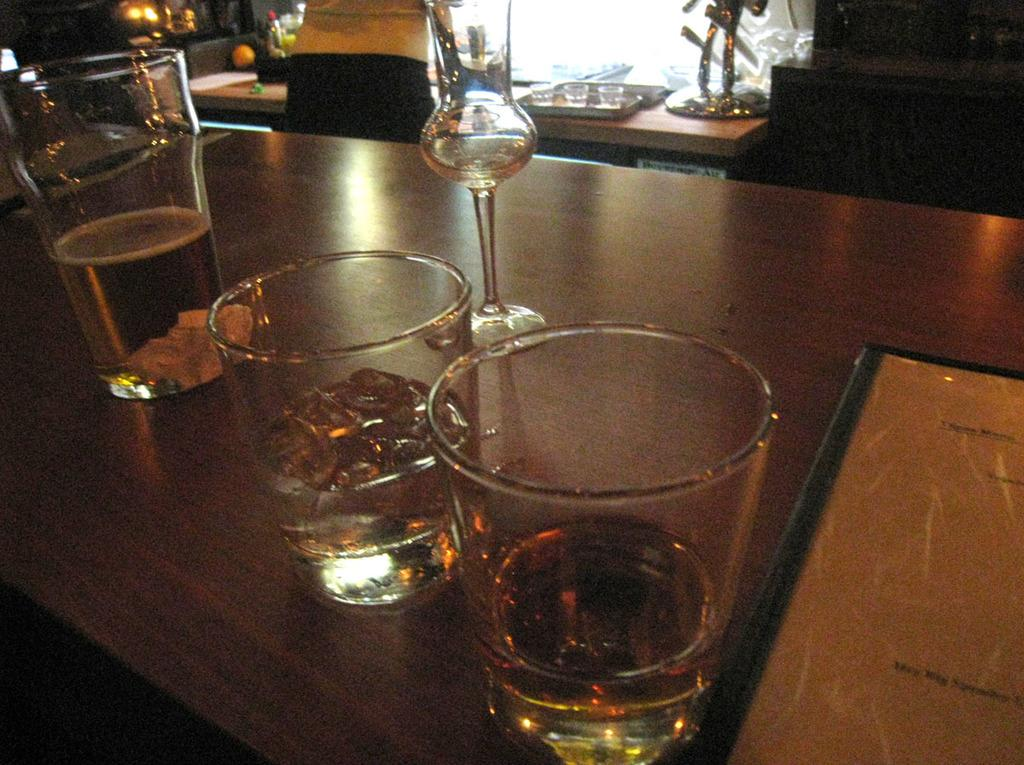What type of furniture is visible in the image? There are tables in the image. What can be found on the tables? There are glass tumblers with beverages, trays, a knife holder, and condiments on the tables. What might be used to hold utensils on the tables? There is a knife holder on the tables. What else might be used for serving or holding items on the tables? Trays are present on the tables. What type of roll can be seen in the image? There is no roll present in the image. What apparatus is used to change the beverages in the glass tumblers? There is no apparatus present in the image for changing the beverages in the glass tumblers. 